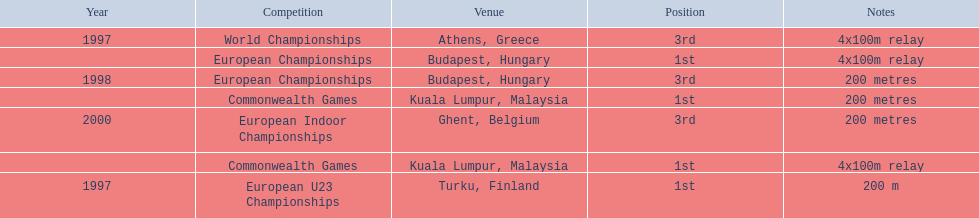In what year did england reach the pinnacle of success in the 200-meter race? 1997. Give me the full table as a dictionary. {'header': ['Year', 'Competition', 'Venue', 'Position', 'Notes'], 'rows': [['1997', 'World Championships', 'Athens, Greece', '3rd', '4x100m relay'], ['', 'European Championships', 'Budapest, Hungary', '1st', '4x100m relay'], ['1998', 'European Championships', 'Budapest, Hungary', '3rd', '200 metres'], ['', 'Commonwealth Games', 'Kuala Lumpur, Malaysia', '1st', '200 metres'], ['2000', 'European Indoor Championships', 'Ghent, Belgium', '3rd', '200 metres'], ['', 'Commonwealth Games', 'Kuala Lumpur, Malaysia', '1st', '4x100m relay'], ['1997', 'European U23 Championships', 'Turku, Finland', '1st', '200 m']]} 